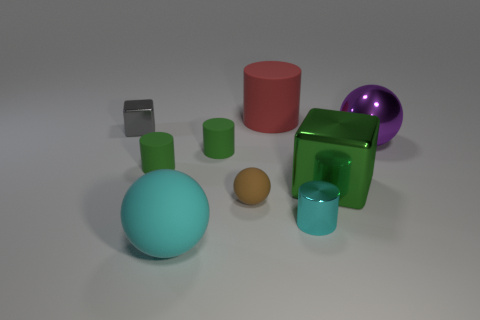Subtract all tiny cyan cylinders. How many cylinders are left? 3 Subtract all gray cubes. How many cubes are left? 1 Subtract all red cubes. How many green cylinders are left? 2 Subtract 1 cyan spheres. How many objects are left? 8 Subtract all balls. How many objects are left? 6 Subtract 3 balls. How many balls are left? 0 Subtract all purple blocks. Subtract all cyan cylinders. How many blocks are left? 2 Subtract all large rubber spheres. Subtract all big red matte things. How many objects are left? 7 Add 8 brown things. How many brown things are left? 9 Add 3 shiny objects. How many shiny objects exist? 7 